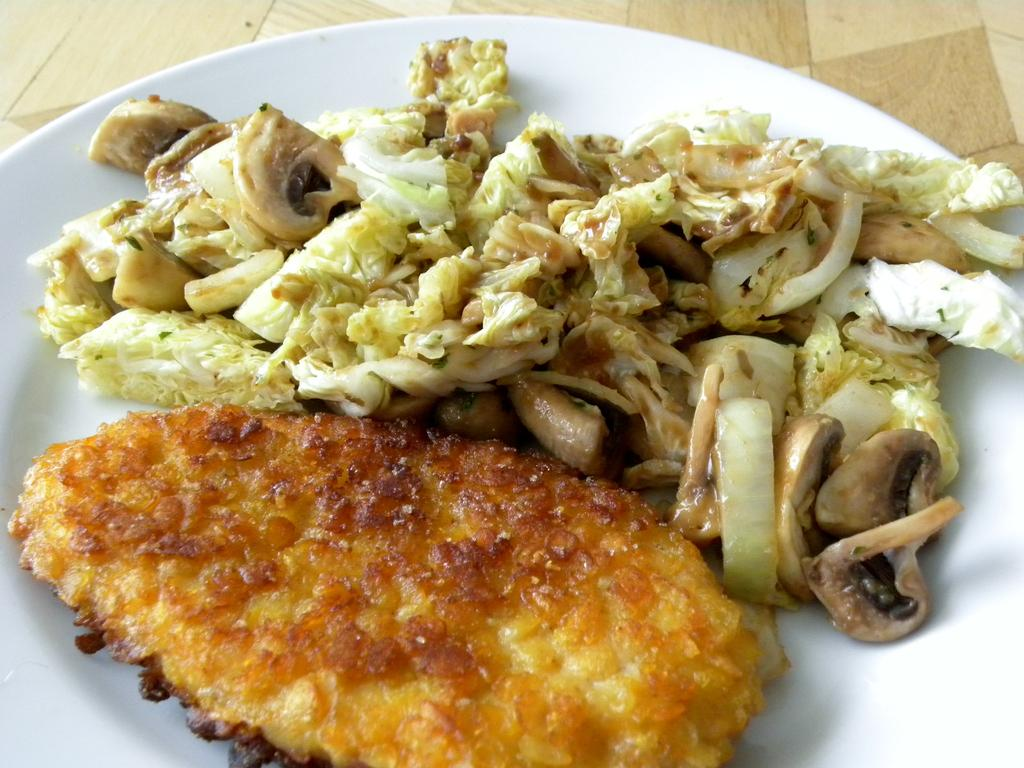What color is the plate that is visible in the image? The plate is white. Where is the plate located in the image? The plate is on a surface. What is on the plate in the image? There are food items on the plate. What type of discovery was made by the grandmother in the image? There is no mention of a discovery or a grandmother in the image; it only features a white plate with food items on it. 